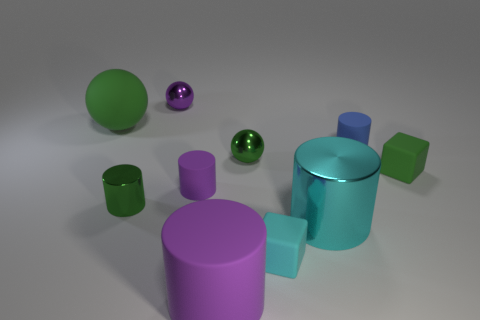What can you tell me about the surface the objects are resting on? The objects are resting on a flat, matte surface that seems neutral in color, probably white or light gray. The surface is smooth, with no visible texture or patterns, providing a plain background that lets the objects stand out. Is there any indication of light source direction in the image? Yes, there are soft shadows cast by the objects, indicating that the light source is coming from the upper left side of the image. The shadows help give a sense of depth and dimension to the scene. 